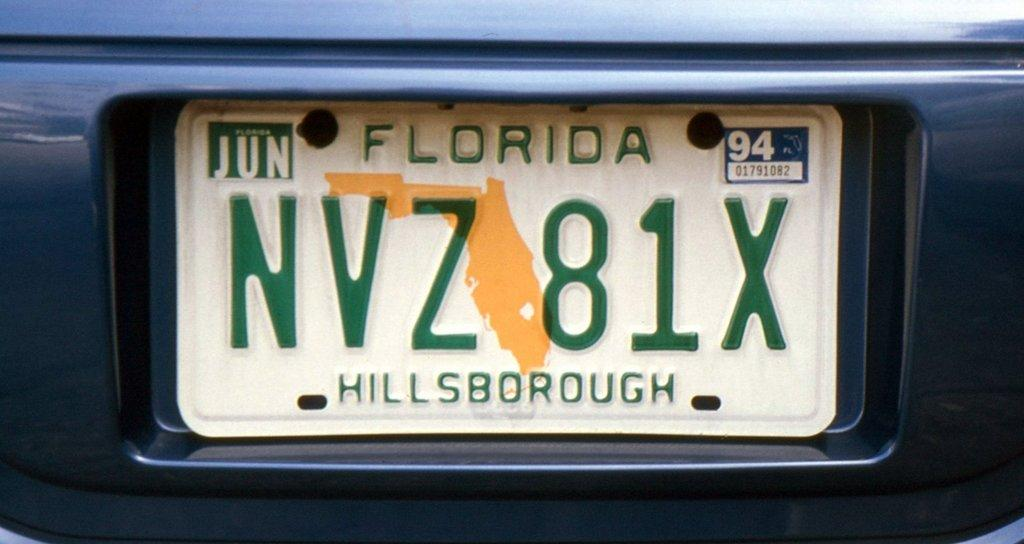<image>
Offer a succinct explanation of the picture presented. a green and white Florida license plate from hillsborough. 